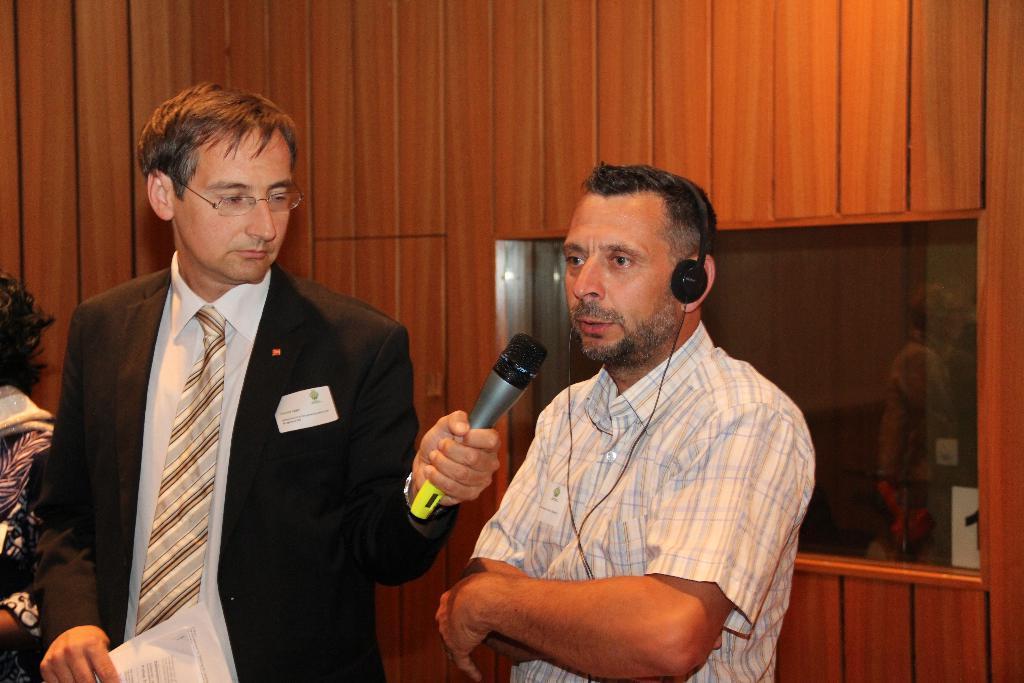How would you summarize this image in a sentence or two? In the image we can see two men standing and wearing clothes. This man is holding a microphone in his one hand and on the other hand, there are spectacles, and he is wearing spectacles. These are the headsets and a glass window. This is a wooden wall and there is another person standing beside this man. 